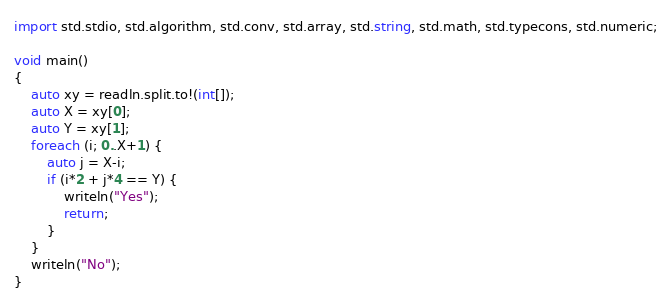<code> <loc_0><loc_0><loc_500><loc_500><_D_>import std.stdio, std.algorithm, std.conv, std.array, std.string, std.math, std.typecons, std.numeric;

void main()
{
    auto xy = readln.split.to!(int[]);
    auto X = xy[0];
    auto Y = xy[1];
    foreach (i; 0..X+1) {
        auto j = X-i;
        if (i*2 + j*4 == Y) {
            writeln("Yes");
            return;
        }
    }
    writeln("No");
}</code> 